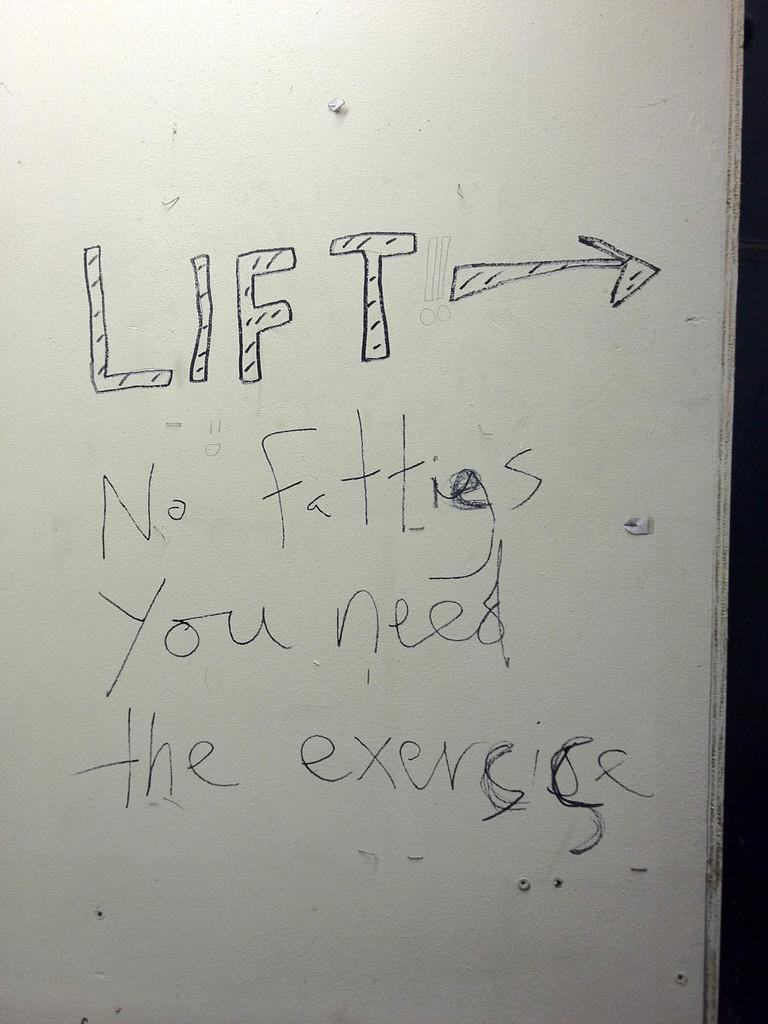<image>
Provide a brief description of the given image. A degrading message to people who are overweight is written on a dry erase board, pointing them to in the direction of a gym. 